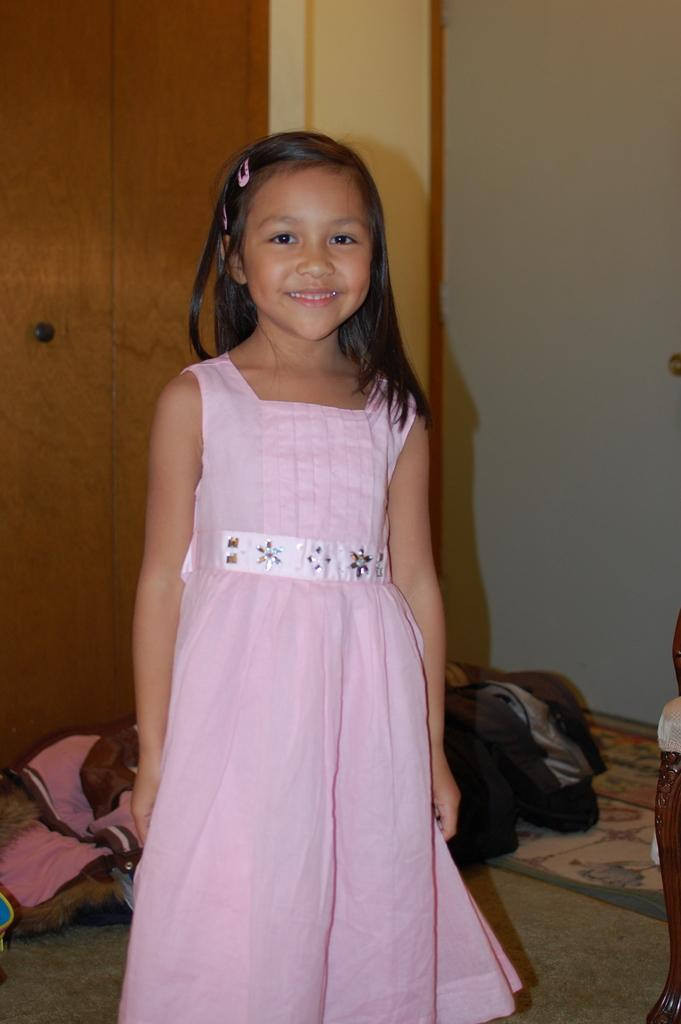Who is the main subject in the image? There is a girl in the image. What is the girl wearing? The girl is wearing a pink dress. What can be seen beneath the girl's feet? There is a floor visible in the image. What is located in the background of the image? There is a cupboard and a wall in the background of the image. What is present on the floor in the image? There are blankets on the floor. What type of locket is the girl holding in the image? There is no locket present in the image; the girl is not holding any object. What experience does the girl have with the governor in the image? There is no governor or any indication of an experience with a governor in the image. 